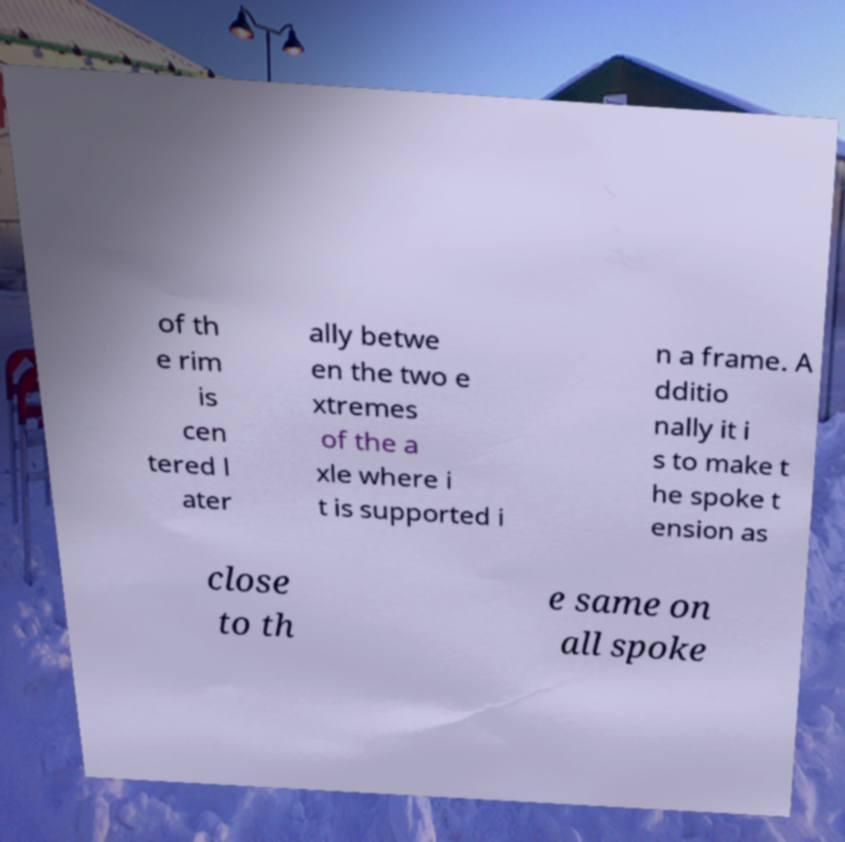What messages or text are displayed in this image? I need them in a readable, typed format. of th e rim is cen tered l ater ally betwe en the two e xtremes of the a xle where i t is supported i n a frame. A dditio nally it i s to make t he spoke t ension as close to th e same on all spoke 